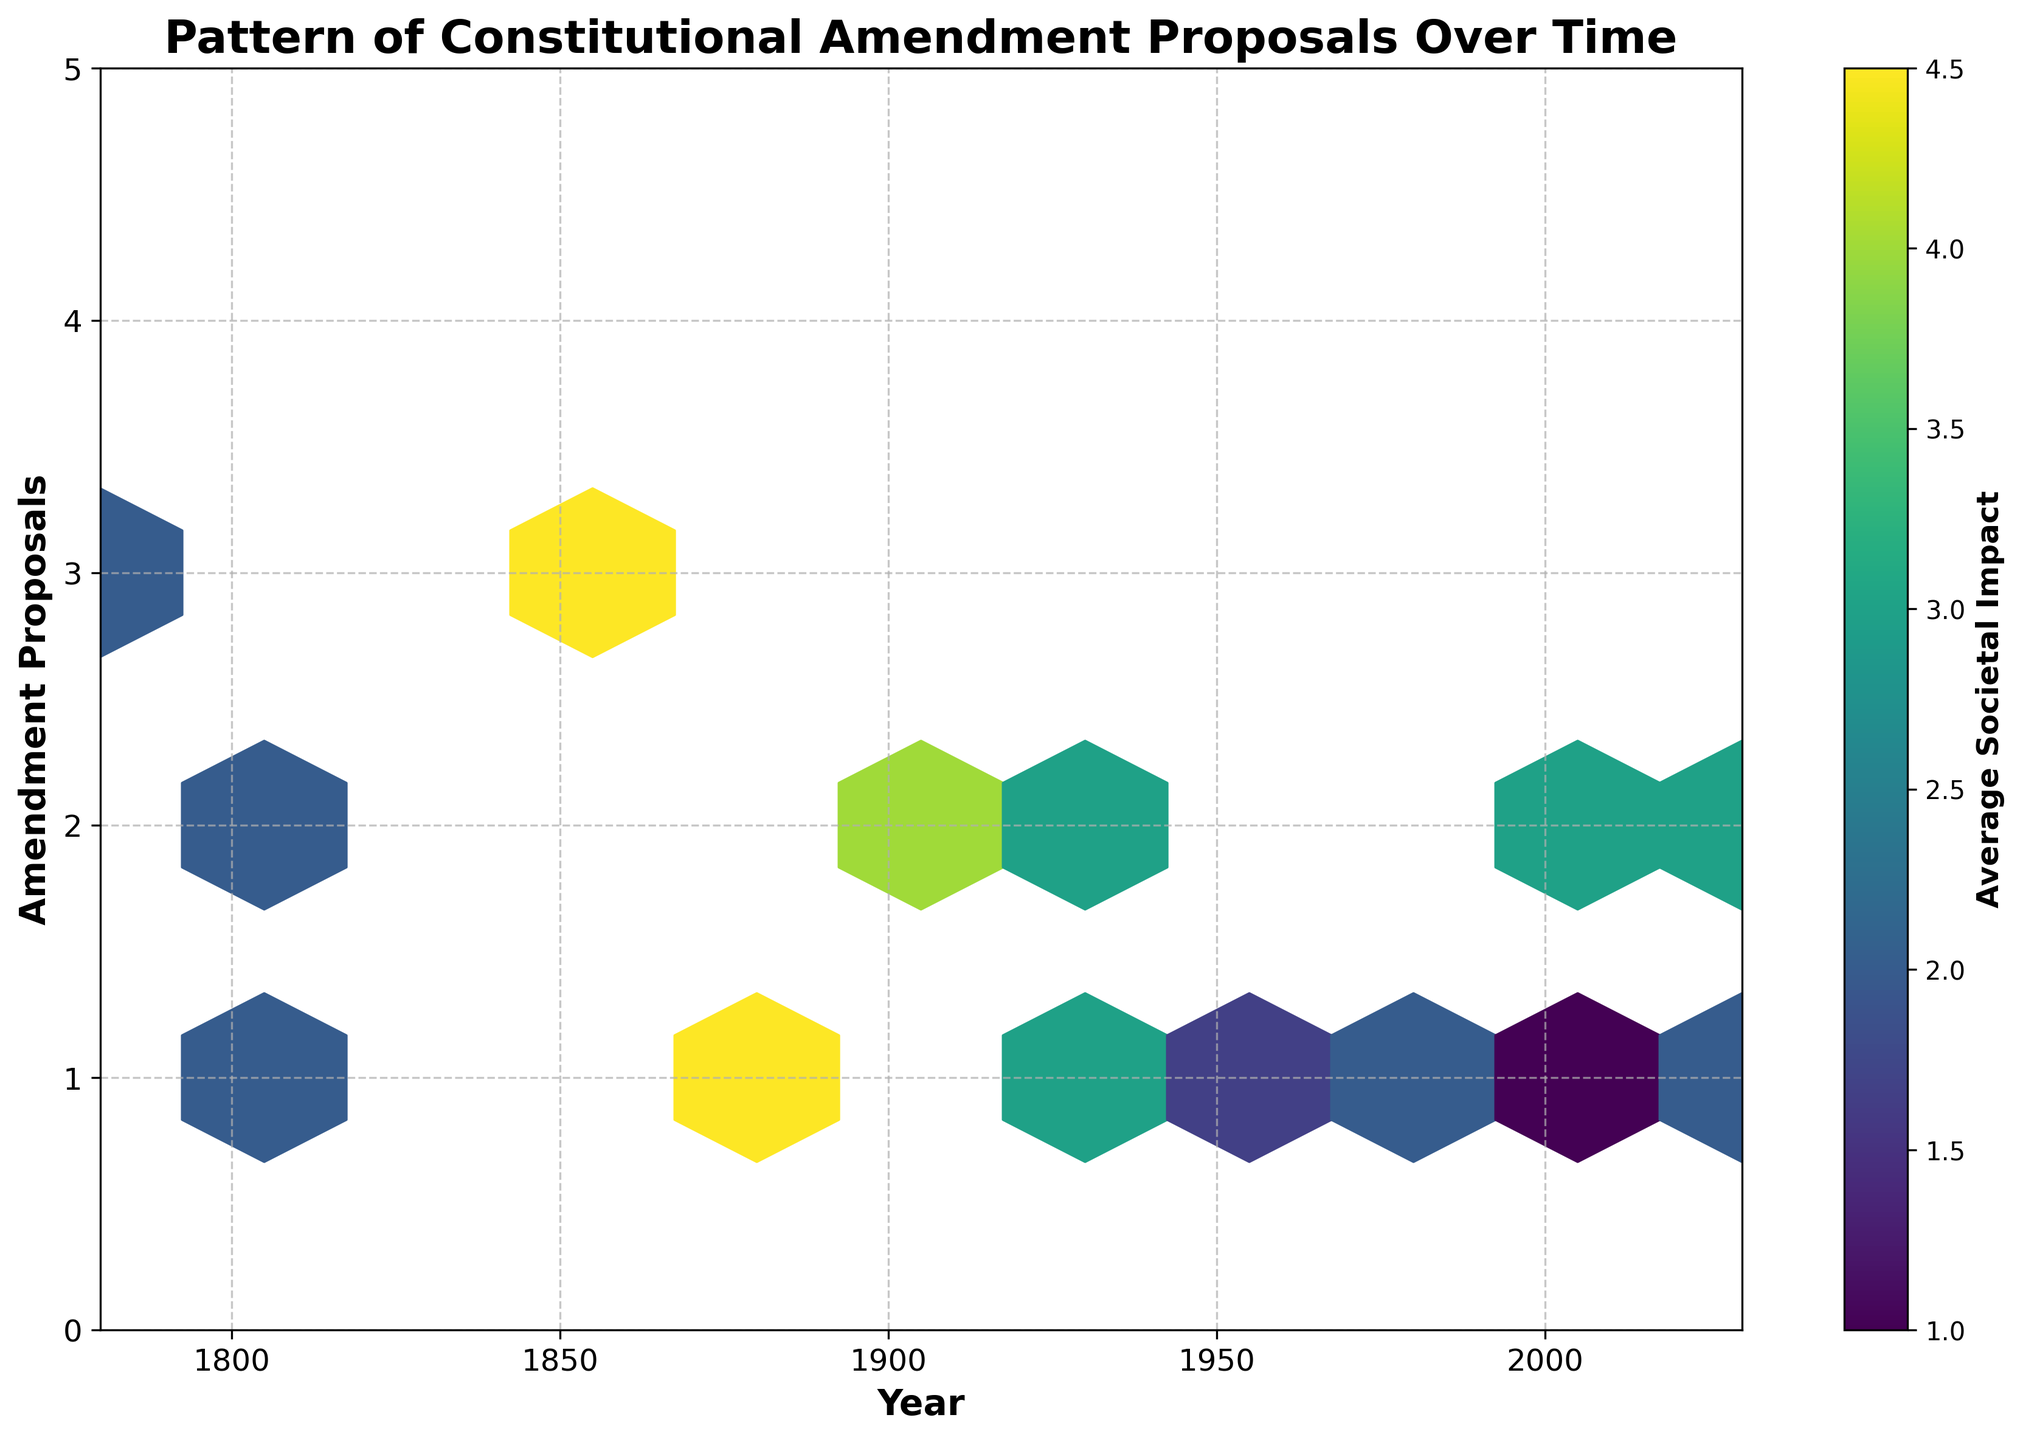What is the title of the plot? The title is typically found at the top of the figure and is visually distinguishable.
Answer: Pattern of Constitutional Amendment Proposals Over Time What do the x-axis and y-axis represent in the plot? The labels on the x-axis and y-axis describe what each axis represents.
Answer: The x-axis represents 'Year' and the y-axis represents 'Amendment Proposals' What does the color bar represent in the plot? The color bar is labeled to indicate what it signifies in the figure.
Answer: Average Societal Impact How many amendment proposals were there around the year 1865? By observing the data points around 1865 on the x-axis and the corresponding y-values on the y-axis, you can determine the number of amendment proposals.
Answer: Around 3 or 4 What is the trend of amendment proposals over time? By looking at the distribution of data points across the years on the hexbin plot, you can observe whether the number of amendment proposals increases, decreases, or remains stable over time.
Answer: The trend is relatively stable with occasional fluctuations Which decade appears to have the highest concentration of amendment proposals? By examining the density of data points for each decade using the hexagons' color and size, you can determine which decade has the highest concentration.
Answer: 1860s How does the average societal impact correlate with the number of amendment proposals? Observing the gradient of colors in the hexbin plot can provide insights into the correlation between societal impact and amendment proposals.
Answer: Higher number of proposals often correspond to higher societal impact, indicated by darker colors What are the ranges of years and amendment proposals displayed in the plot? The x-axis and y-axis limits indicate the ranges covered in the plot.
Answer: Years: 1780 to 2030, Amendment Proposals: 0 to 5 Is there any period without any amendment proposals? By examining gaps in the distribution of hexagons along the x-axis, you can identify periods with no data points.
Answer: Yes, several periods especially in the 1800s and late 20th century have no proposals In which year do you see the highest average societal impact associated with amendment proposals? By identifying the darkest hexagons on the color scale and locating their x-axis value, you can find the year with the highest societal impact.
Answer: Around 1861 